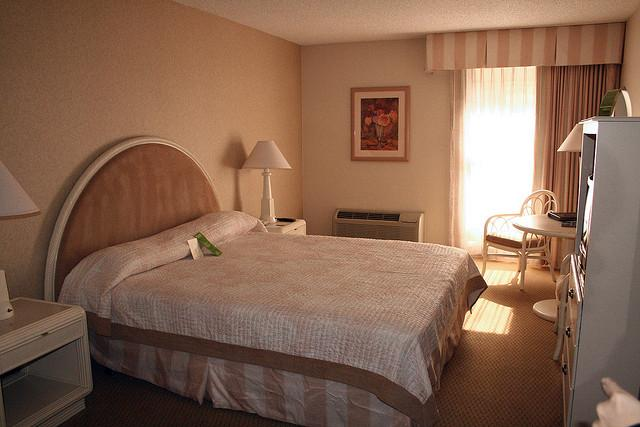What venue is shown here?

Choices:
A) hotel room
B) apartment
C) studio
D) bedroom hotel room 